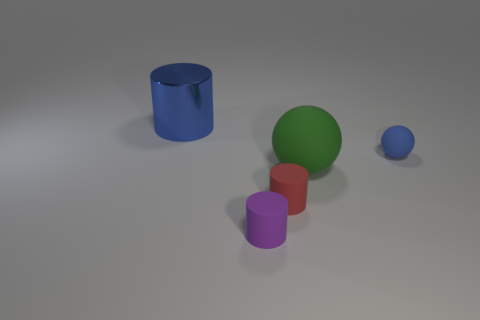What materials do these objects appear to be made of? The objects in the image have a matte appearance and seem to simulate materials that could be either plastic or rubber, given their non-reflective and smooth surfaces. 